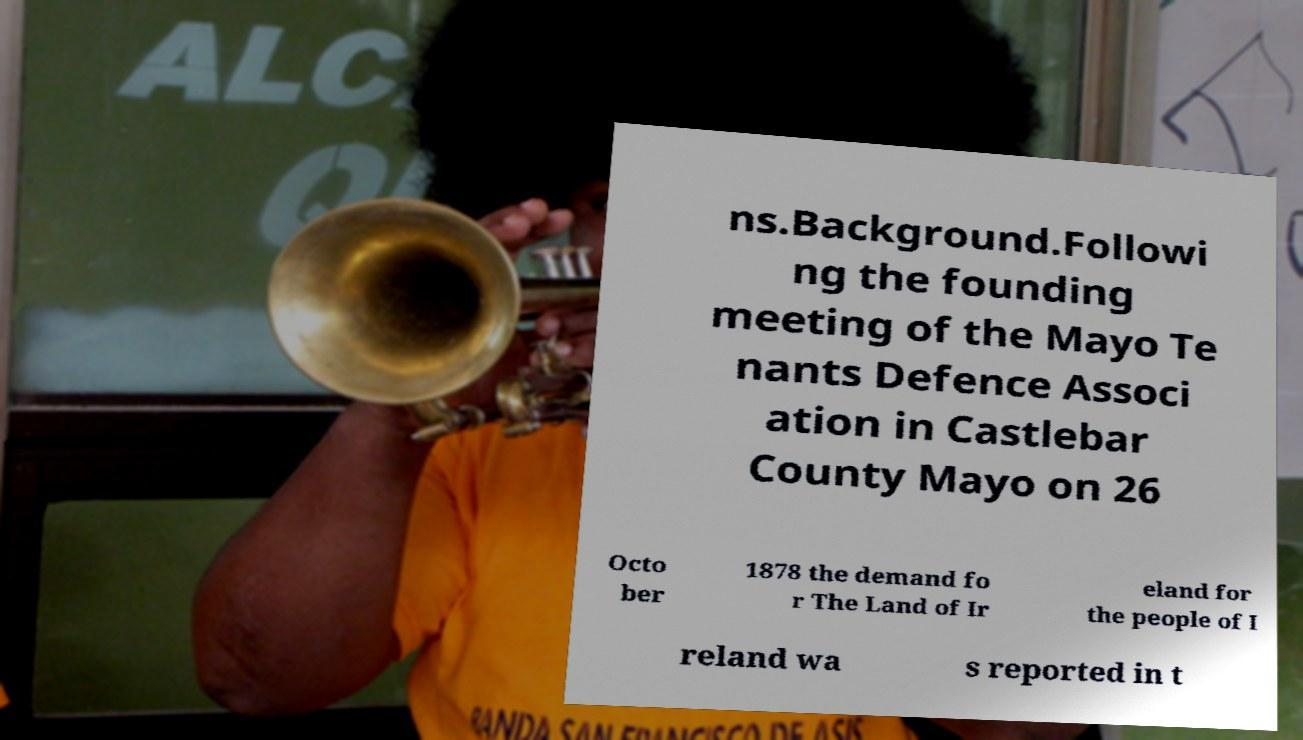Please identify and transcribe the text found in this image. ns.Background.Followi ng the founding meeting of the Mayo Te nants Defence Associ ation in Castlebar County Mayo on 26 Octo ber 1878 the demand fo r The Land of Ir eland for the people of I reland wa s reported in t 